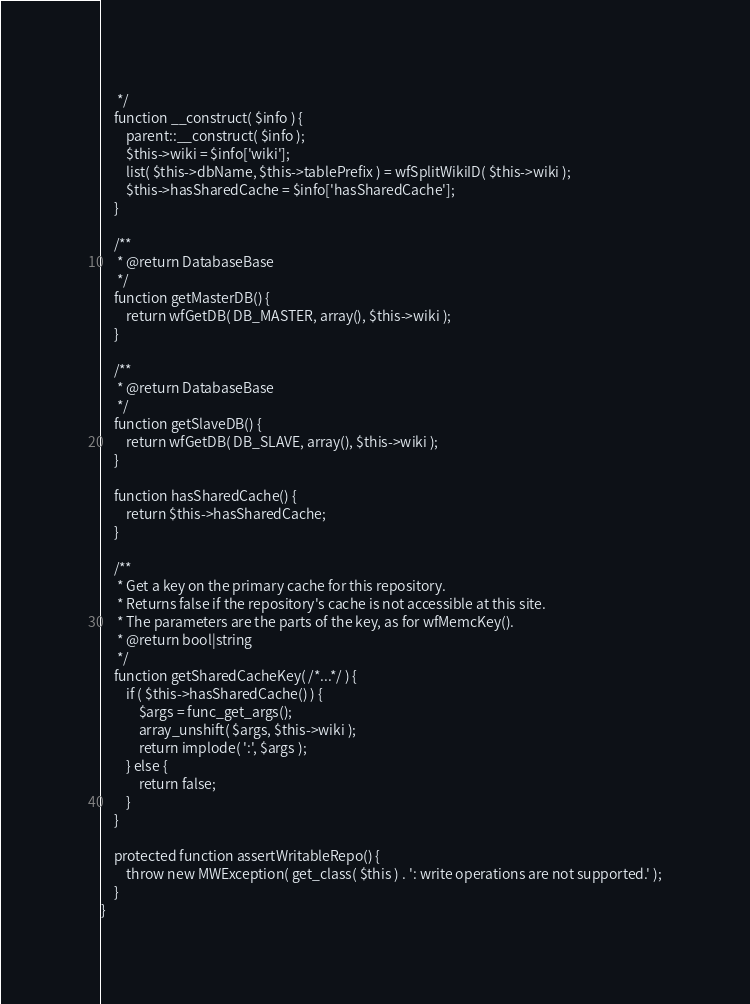Convert code to text. <code><loc_0><loc_0><loc_500><loc_500><_PHP_>	 */
	function __construct( $info ) {
		parent::__construct( $info );
		$this->wiki = $info['wiki'];
		list( $this->dbName, $this->tablePrefix ) = wfSplitWikiID( $this->wiki );
		$this->hasSharedCache = $info['hasSharedCache'];
	}

	/**
	 * @return DatabaseBase
	 */
	function getMasterDB() {
		return wfGetDB( DB_MASTER, array(), $this->wiki );
	}

	/**
	 * @return DatabaseBase
	 */
	function getSlaveDB() {
		return wfGetDB( DB_SLAVE, array(), $this->wiki );
	}

	function hasSharedCache() {
		return $this->hasSharedCache;
	}

	/**
	 * Get a key on the primary cache for this repository.
	 * Returns false if the repository's cache is not accessible at this site.
	 * The parameters are the parts of the key, as for wfMemcKey().
	 * @return bool|string
	 */
	function getSharedCacheKey( /*...*/ ) {
		if ( $this->hasSharedCache() ) {
			$args = func_get_args();
			array_unshift( $args, $this->wiki );
			return implode( ':', $args );
		} else {
			return false;
		}
	}

	protected function assertWritableRepo() {
		throw new MWException( get_class( $this ) . ': write operations are not supported.' );
	}
}
</code> 